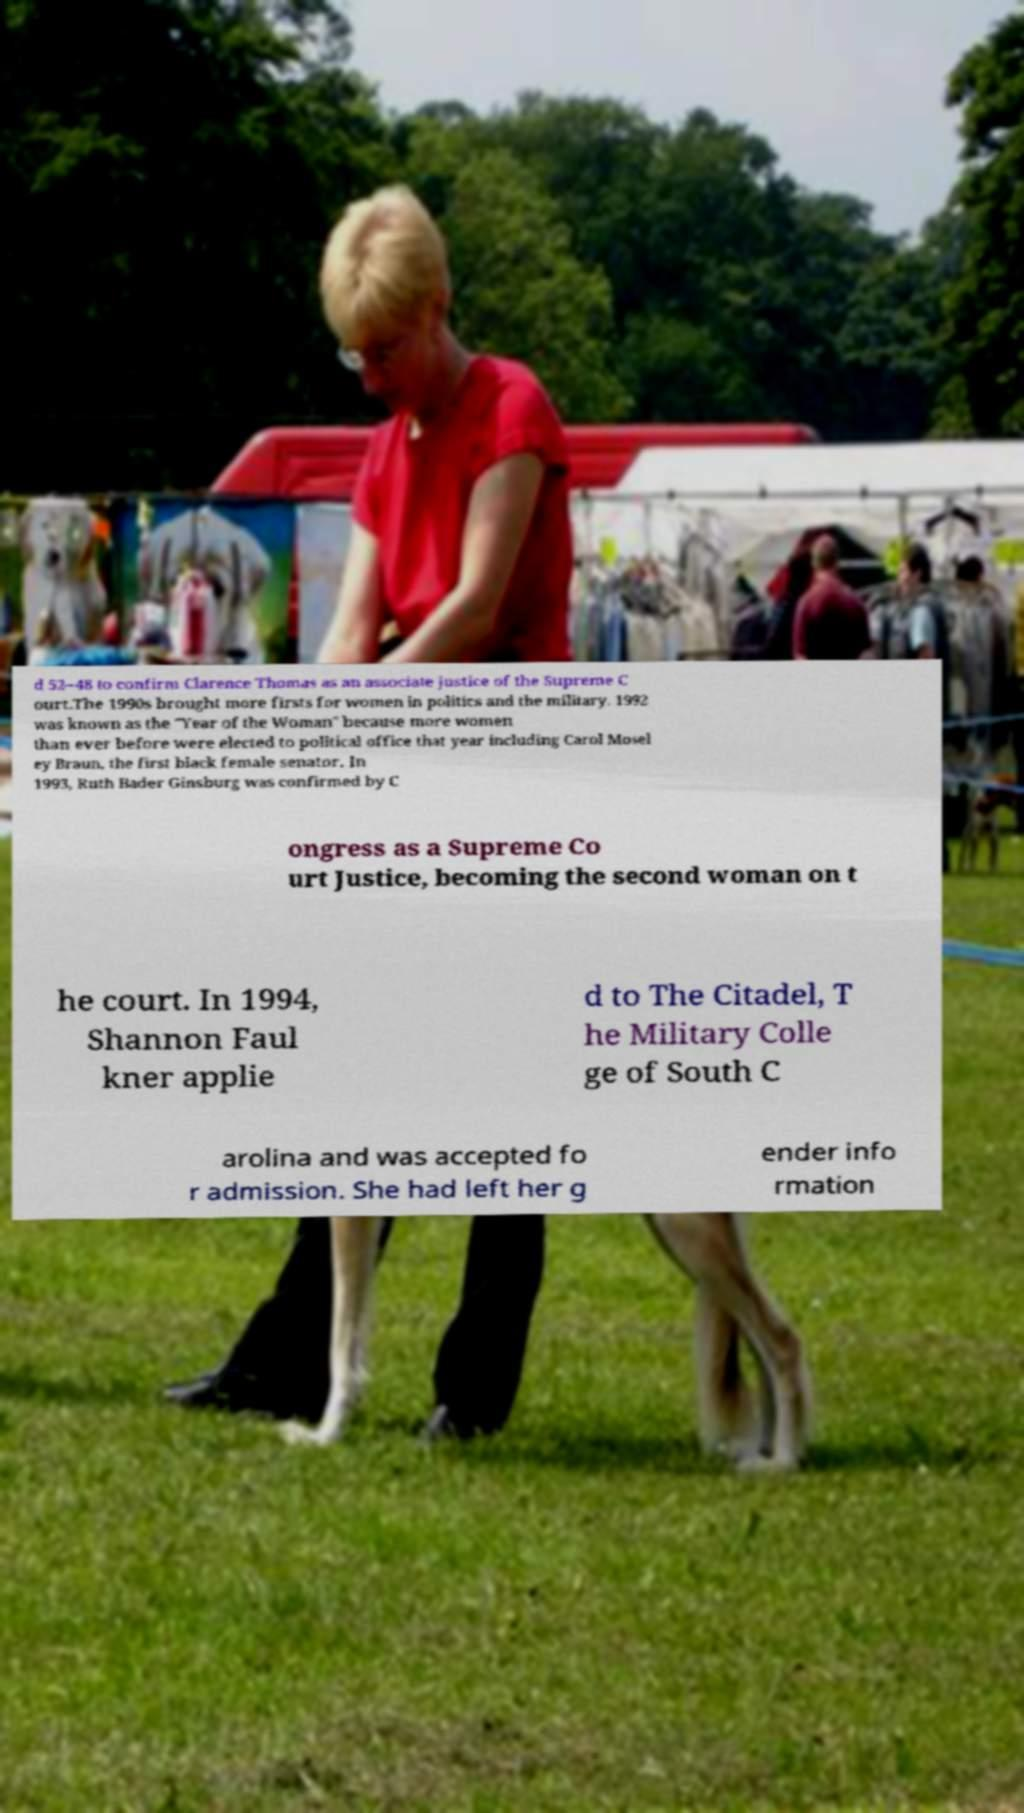Can you read and provide the text displayed in the image?This photo seems to have some interesting text. Can you extract and type it out for me? d 52–48 to confirm Clarence Thomas as an associate justice of the Supreme C ourt.The 1990s brought more firsts for women in politics and the military. 1992 was known as the "Year of the Woman" because more women than ever before were elected to political office that year including Carol Mosel ey Braun, the first black female senator. In 1993, Ruth Bader Ginsburg was confirmed by C ongress as a Supreme Co urt Justice, becoming the second woman on t he court. In 1994, Shannon Faul kner applie d to The Citadel, T he Military Colle ge of South C arolina and was accepted fo r admission. She had left her g ender info rmation 